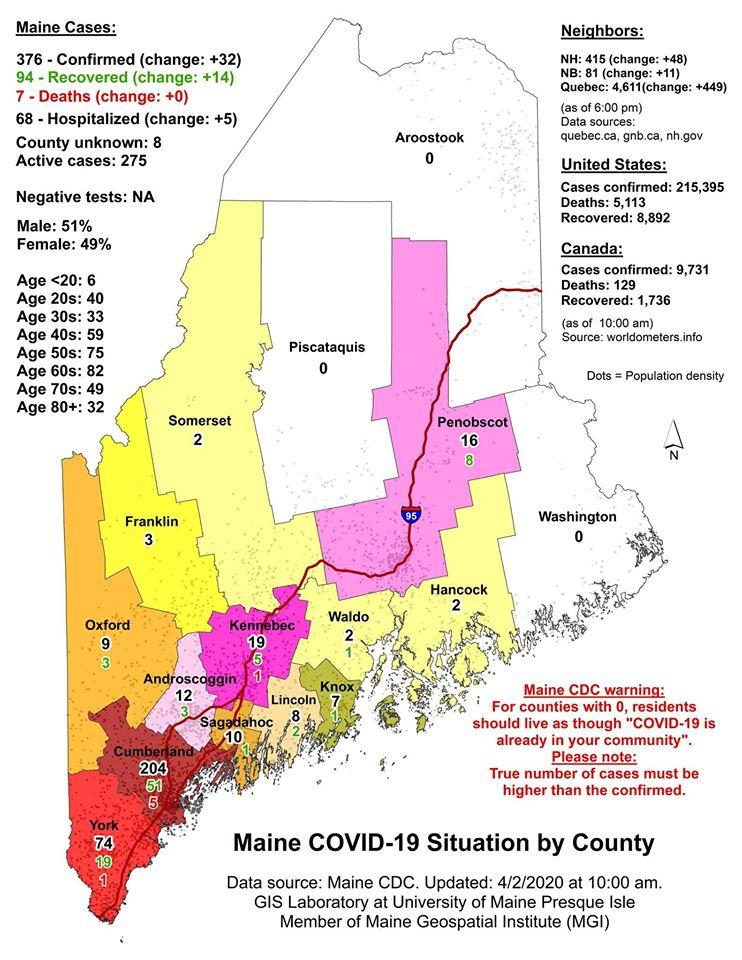Indicate a few pertinent items in this graphic. As of April 2, 2020, there have been seven reported deaths in the state of Maine due to Covid-19 in the United States. According to the latest data available as of April 2, 2020, Cumberland County in Maine has reported the highest number of COVID-19 deaths. As of April 2, 2020, the reported number of deaths in Kennebec county due to Covid-19 was 1. As of April 2, 2020, Cumberland County in Maine has reported the highest number of confirmed COVID-19 cases. As of April 2, 2020, there were 5 reported deaths due to Covid-19 in Cumberland. 